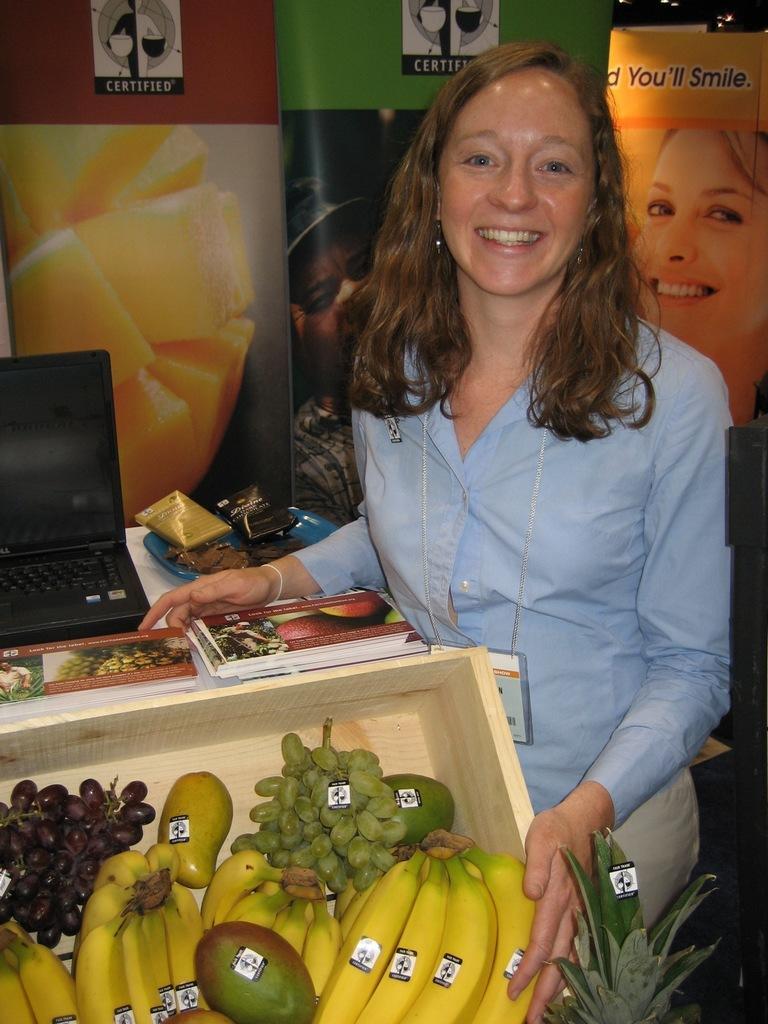Please provide a concise description of this image. In this image there is a woman standing. Left bottom there is a basket having mangoes, bananas, grapes. Left side there is a table having laptop, books and few objects. Background there are banners. 